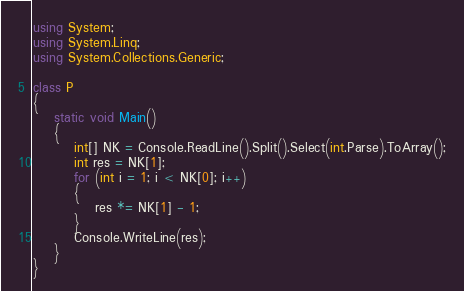<code> <loc_0><loc_0><loc_500><loc_500><_C#_>using System;
using System.Linq;
using System.Collections.Generic;

class P
{
    static void Main()
    {
        int[] NK = Console.ReadLine().Split().Select(int.Parse).ToArray();
        int res = NK[1];
        for (int i = 1; i < NK[0]; i++)
        {
            res *= NK[1] - 1;
        }
        Console.WriteLine(res);
    }
}</code> 